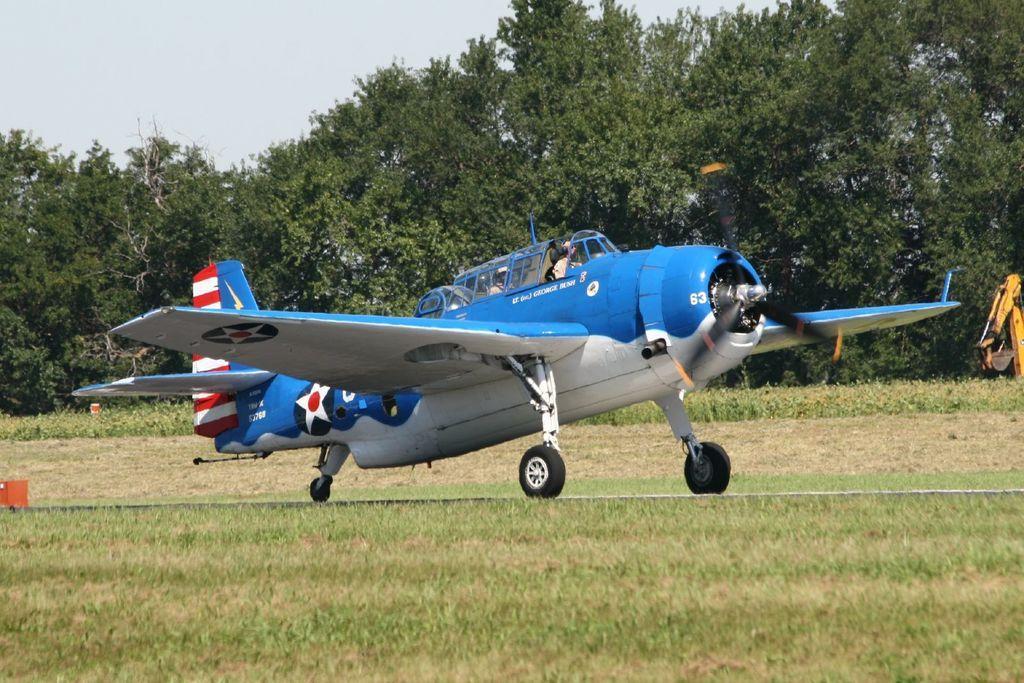Can you describe this image briefly? In this picture we can see a utility aircraft on the grass ground surrounded by trees. 